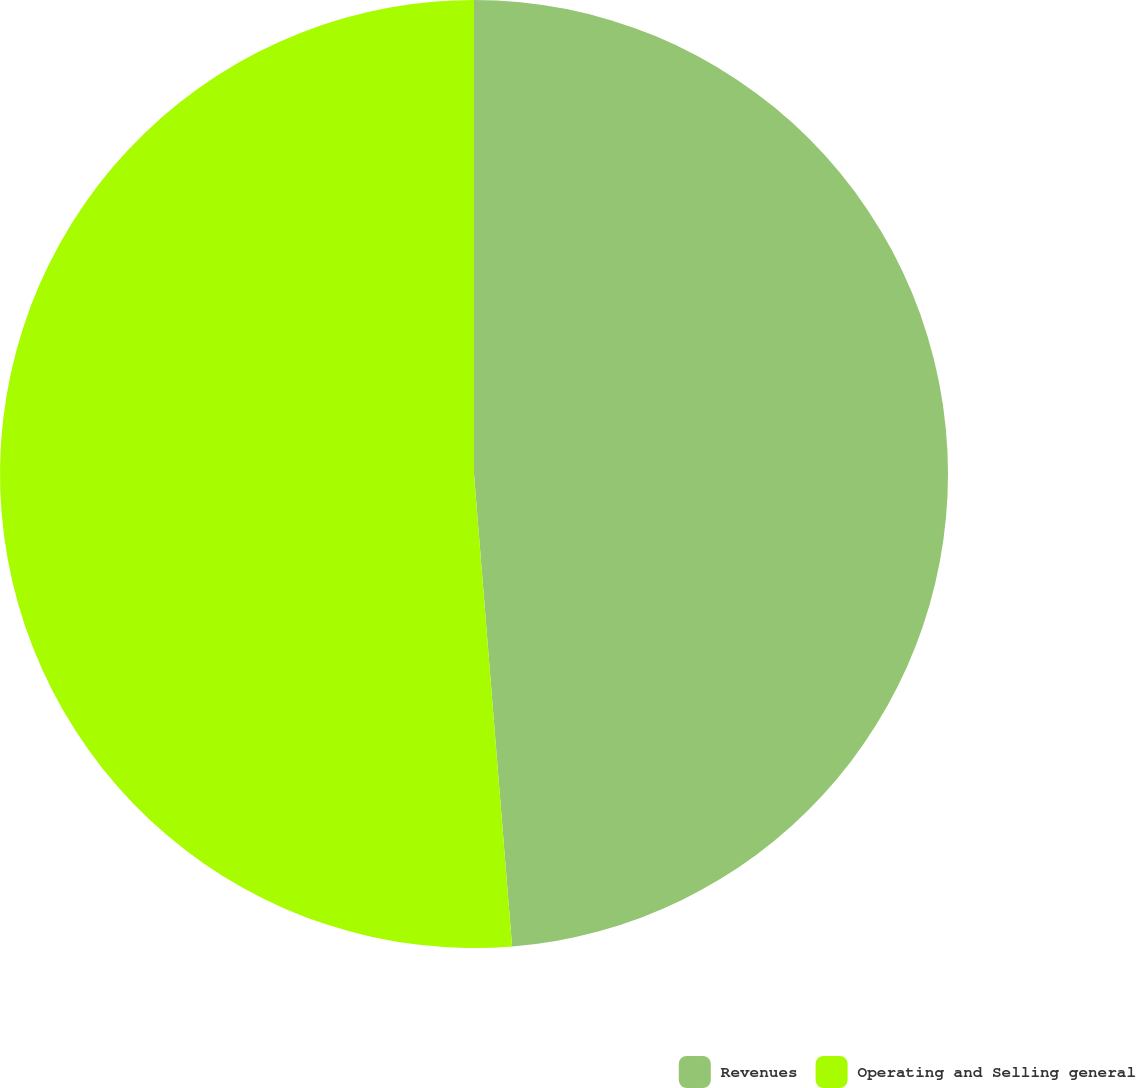<chart> <loc_0><loc_0><loc_500><loc_500><pie_chart><fcel>Revenues<fcel>Operating and Selling general<nl><fcel>48.72%<fcel>51.28%<nl></chart> 